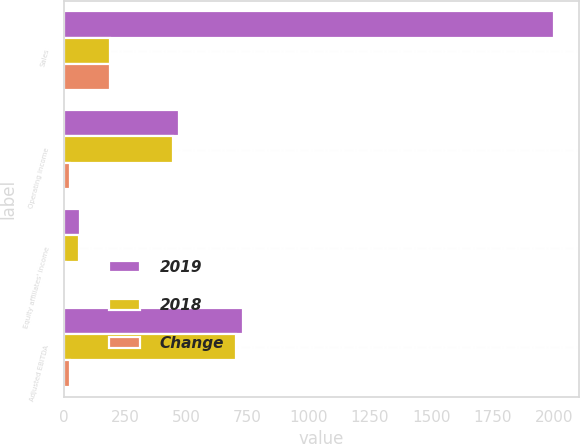<chart> <loc_0><loc_0><loc_500><loc_500><stacked_bar_chart><ecel><fcel>Sales<fcel>Operating income<fcel>Equity affiliates' income<fcel>Adjusted EBITDA<nl><fcel>2019<fcel>2002.5<fcel>472.4<fcel>69<fcel>730.9<nl><fcel>2018<fcel>190.8<fcel>445.8<fcel>61.1<fcel>705.5<nl><fcel>Change<fcel>190.8<fcel>26.6<fcel>7.9<fcel>25.4<nl></chart> 